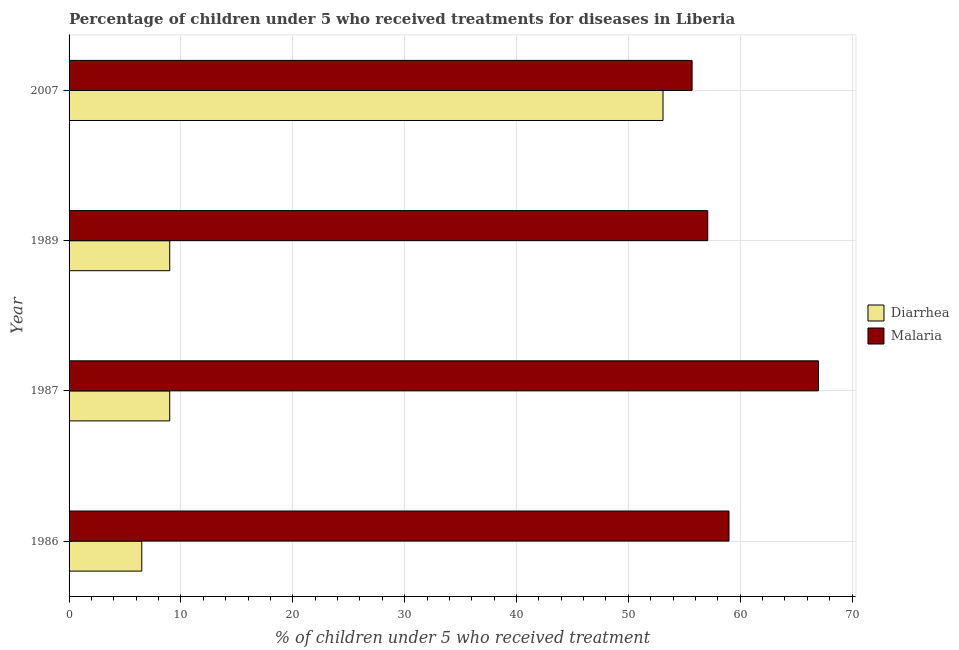How many groups of bars are there?
Offer a terse response. 4. Are the number of bars on each tick of the Y-axis equal?
Offer a very short reply. Yes. How many bars are there on the 4th tick from the top?
Ensure brevity in your answer.  2. What is the label of the 2nd group of bars from the top?
Your response must be concise. 1989. In how many cases, is the number of bars for a given year not equal to the number of legend labels?
Your response must be concise. 0. Across all years, what is the maximum percentage of children who received treatment for diarrhoea?
Your response must be concise. 53.1. In which year was the percentage of children who received treatment for malaria maximum?
Your answer should be compact. 1987. In which year was the percentage of children who received treatment for malaria minimum?
Keep it short and to the point. 2007. What is the total percentage of children who received treatment for diarrhoea in the graph?
Your answer should be very brief. 77.6. What is the difference between the percentage of children who received treatment for diarrhoea in 1986 and the percentage of children who received treatment for malaria in 1989?
Provide a succinct answer. -50.6. What is the average percentage of children who received treatment for malaria per year?
Your response must be concise. 59.7. In the year 1987, what is the difference between the percentage of children who received treatment for diarrhoea and percentage of children who received treatment for malaria?
Provide a short and direct response. -58. In how many years, is the percentage of children who received treatment for diarrhoea greater than 10 %?
Provide a short and direct response. 1. What is the ratio of the percentage of children who received treatment for diarrhoea in 1989 to that in 2007?
Provide a succinct answer. 0.17. What is the difference between the highest and the second highest percentage of children who received treatment for diarrhoea?
Give a very brief answer. 44.1. What does the 1st bar from the top in 2007 represents?
Your answer should be very brief. Malaria. What does the 1st bar from the bottom in 1986 represents?
Give a very brief answer. Diarrhea. How many years are there in the graph?
Give a very brief answer. 4. What is the difference between two consecutive major ticks on the X-axis?
Provide a short and direct response. 10. Does the graph contain any zero values?
Give a very brief answer. No. Does the graph contain grids?
Your response must be concise. Yes. Where does the legend appear in the graph?
Offer a terse response. Center right. What is the title of the graph?
Provide a short and direct response. Percentage of children under 5 who received treatments for diseases in Liberia. Does "Techinal cooperation" appear as one of the legend labels in the graph?
Offer a terse response. No. What is the label or title of the X-axis?
Your answer should be very brief. % of children under 5 who received treatment. What is the label or title of the Y-axis?
Your answer should be very brief. Year. What is the % of children under 5 who received treatment of Diarrhea in 1986?
Give a very brief answer. 6.5. What is the % of children under 5 who received treatment in Malaria in 1986?
Your answer should be compact. 59. What is the % of children under 5 who received treatment in Diarrhea in 1987?
Offer a terse response. 9. What is the % of children under 5 who received treatment of Malaria in 1987?
Make the answer very short. 67. What is the % of children under 5 who received treatment of Malaria in 1989?
Give a very brief answer. 57.1. What is the % of children under 5 who received treatment in Diarrhea in 2007?
Give a very brief answer. 53.1. What is the % of children under 5 who received treatment of Malaria in 2007?
Your answer should be compact. 55.7. Across all years, what is the maximum % of children under 5 who received treatment of Diarrhea?
Offer a very short reply. 53.1. Across all years, what is the minimum % of children under 5 who received treatment in Malaria?
Provide a succinct answer. 55.7. What is the total % of children under 5 who received treatment of Diarrhea in the graph?
Offer a very short reply. 77.6. What is the total % of children under 5 who received treatment of Malaria in the graph?
Provide a succinct answer. 238.8. What is the difference between the % of children under 5 who received treatment of Diarrhea in 1986 and that in 2007?
Your answer should be very brief. -46.6. What is the difference between the % of children under 5 who received treatment in Malaria in 1987 and that in 1989?
Your answer should be compact. 9.9. What is the difference between the % of children under 5 who received treatment in Diarrhea in 1987 and that in 2007?
Make the answer very short. -44.1. What is the difference between the % of children under 5 who received treatment of Malaria in 1987 and that in 2007?
Offer a very short reply. 11.3. What is the difference between the % of children under 5 who received treatment in Diarrhea in 1989 and that in 2007?
Provide a succinct answer. -44.1. What is the difference between the % of children under 5 who received treatment of Malaria in 1989 and that in 2007?
Your response must be concise. 1.4. What is the difference between the % of children under 5 who received treatment of Diarrhea in 1986 and the % of children under 5 who received treatment of Malaria in 1987?
Provide a short and direct response. -60.5. What is the difference between the % of children under 5 who received treatment in Diarrhea in 1986 and the % of children under 5 who received treatment in Malaria in 1989?
Give a very brief answer. -50.6. What is the difference between the % of children under 5 who received treatment of Diarrhea in 1986 and the % of children under 5 who received treatment of Malaria in 2007?
Offer a terse response. -49.2. What is the difference between the % of children under 5 who received treatment of Diarrhea in 1987 and the % of children under 5 who received treatment of Malaria in 1989?
Your answer should be very brief. -48.1. What is the difference between the % of children under 5 who received treatment in Diarrhea in 1987 and the % of children under 5 who received treatment in Malaria in 2007?
Give a very brief answer. -46.7. What is the difference between the % of children under 5 who received treatment of Diarrhea in 1989 and the % of children under 5 who received treatment of Malaria in 2007?
Keep it short and to the point. -46.7. What is the average % of children under 5 who received treatment in Malaria per year?
Ensure brevity in your answer.  59.7. In the year 1986, what is the difference between the % of children under 5 who received treatment in Diarrhea and % of children under 5 who received treatment in Malaria?
Make the answer very short. -52.5. In the year 1987, what is the difference between the % of children under 5 who received treatment of Diarrhea and % of children under 5 who received treatment of Malaria?
Your response must be concise. -58. In the year 1989, what is the difference between the % of children under 5 who received treatment in Diarrhea and % of children under 5 who received treatment in Malaria?
Your answer should be compact. -48.1. What is the ratio of the % of children under 5 who received treatment of Diarrhea in 1986 to that in 1987?
Offer a very short reply. 0.72. What is the ratio of the % of children under 5 who received treatment of Malaria in 1986 to that in 1987?
Provide a short and direct response. 0.88. What is the ratio of the % of children under 5 who received treatment of Diarrhea in 1986 to that in 1989?
Your answer should be compact. 0.72. What is the ratio of the % of children under 5 who received treatment of Malaria in 1986 to that in 1989?
Your response must be concise. 1.03. What is the ratio of the % of children under 5 who received treatment of Diarrhea in 1986 to that in 2007?
Provide a short and direct response. 0.12. What is the ratio of the % of children under 5 who received treatment in Malaria in 1986 to that in 2007?
Make the answer very short. 1.06. What is the ratio of the % of children under 5 who received treatment in Diarrhea in 1987 to that in 1989?
Provide a succinct answer. 1. What is the ratio of the % of children under 5 who received treatment of Malaria in 1987 to that in 1989?
Provide a succinct answer. 1.17. What is the ratio of the % of children under 5 who received treatment in Diarrhea in 1987 to that in 2007?
Make the answer very short. 0.17. What is the ratio of the % of children under 5 who received treatment of Malaria in 1987 to that in 2007?
Provide a succinct answer. 1.2. What is the ratio of the % of children under 5 who received treatment in Diarrhea in 1989 to that in 2007?
Your answer should be very brief. 0.17. What is the ratio of the % of children under 5 who received treatment of Malaria in 1989 to that in 2007?
Provide a succinct answer. 1.03. What is the difference between the highest and the second highest % of children under 5 who received treatment in Diarrhea?
Offer a terse response. 44.1. What is the difference between the highest and the second highest % of children under 5 who received treatment of Malaria?
Ensure brevity in your answer.  8. What is the difference between the highest and the lowest % of children under 5 who received treatment in Diarrhea?
Give a very brief answer. 46.6. 